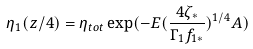<formula> <loc_0><loc_0><loc_500><loc_500>\eta _ { 1 } ( z / 4 ) = \eta _ { t o t } \exp ( - E ( \frac { 4 \zeta _ { * } } { \Gamma _ { 1 } f _ { 1 * } } ) ^ { 1 / 4 } A )</formula> 